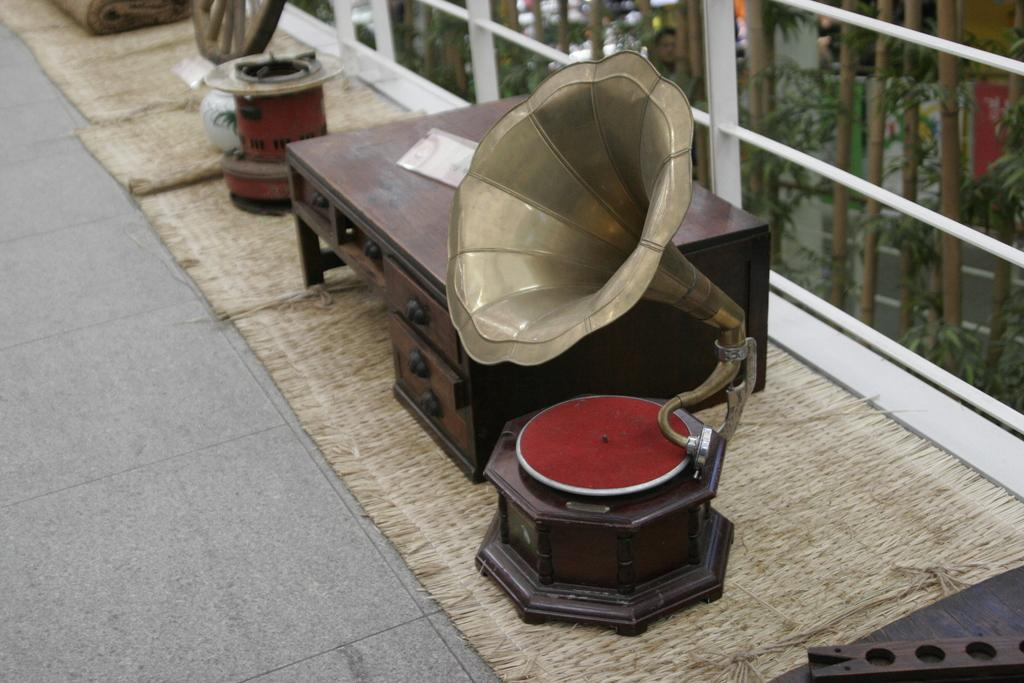What type of furniture is present in the image? There is a wooden table in the image. What object related to music can be seen in the image? There is a musical instrument in the image. What type of windows are visible in the image? There are glass windows in the image. Can you see any wine being poured from a bottle in the image? There is no wine or bottle present in the image. Is there any smoke visible coming from the musical instrument in the image? There is no smoke visible in the image, and the musical instrument is not actively being played. 